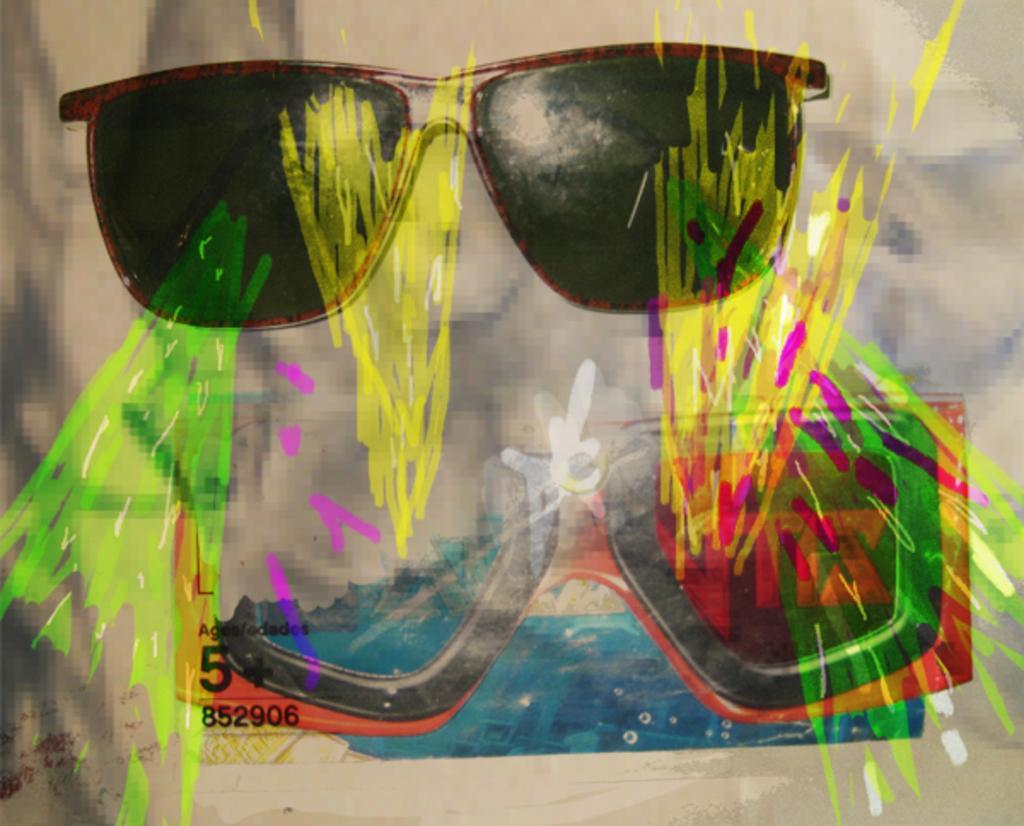In one or two sentences, can you explain what this image depicts? This is an edited picture. In this picture there are spectacles and paintings. 